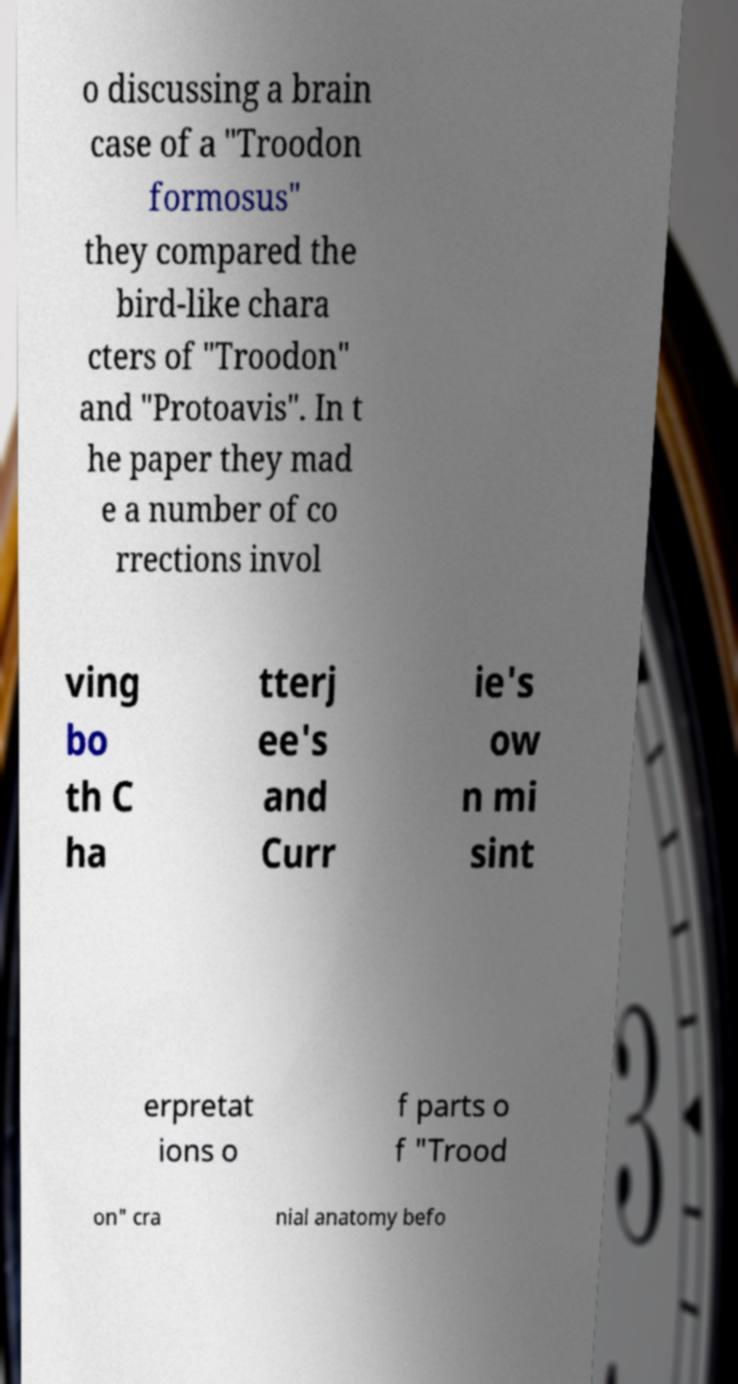Please read and relay the text visible in this image. What does it say? o discussing a brain case of a "Troodon formosus" they compared the bird-like chara cters of "Troodon" and "Protoavis". In t he paper they mad e a number of co rrections invol ving bo th C ha tterj ee's and Curr ie's ow n mi sint erpretat ions o f parts o f "Trood on" cra nial anatomy befo 